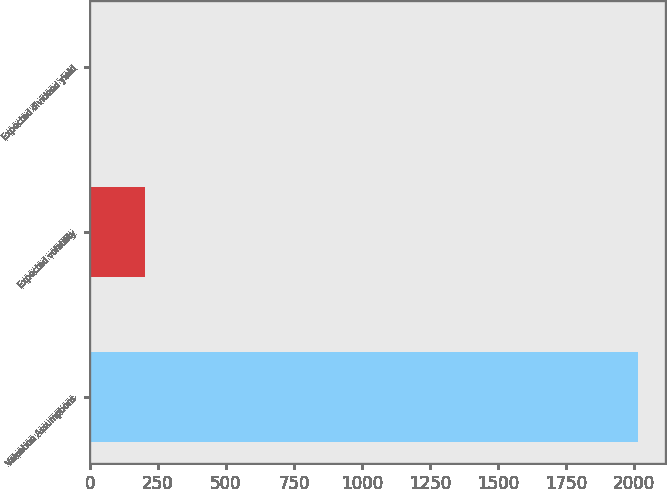<chart> <loc_0><loc_0><loc_500><loc_500><bar_chart><fcel>Valuation Assumptions<fcel>Expected volatility<fcel>Expected dividend yield<nl><fcel>2014<fcel>201.47<fcel>0.08<nl></chart> 